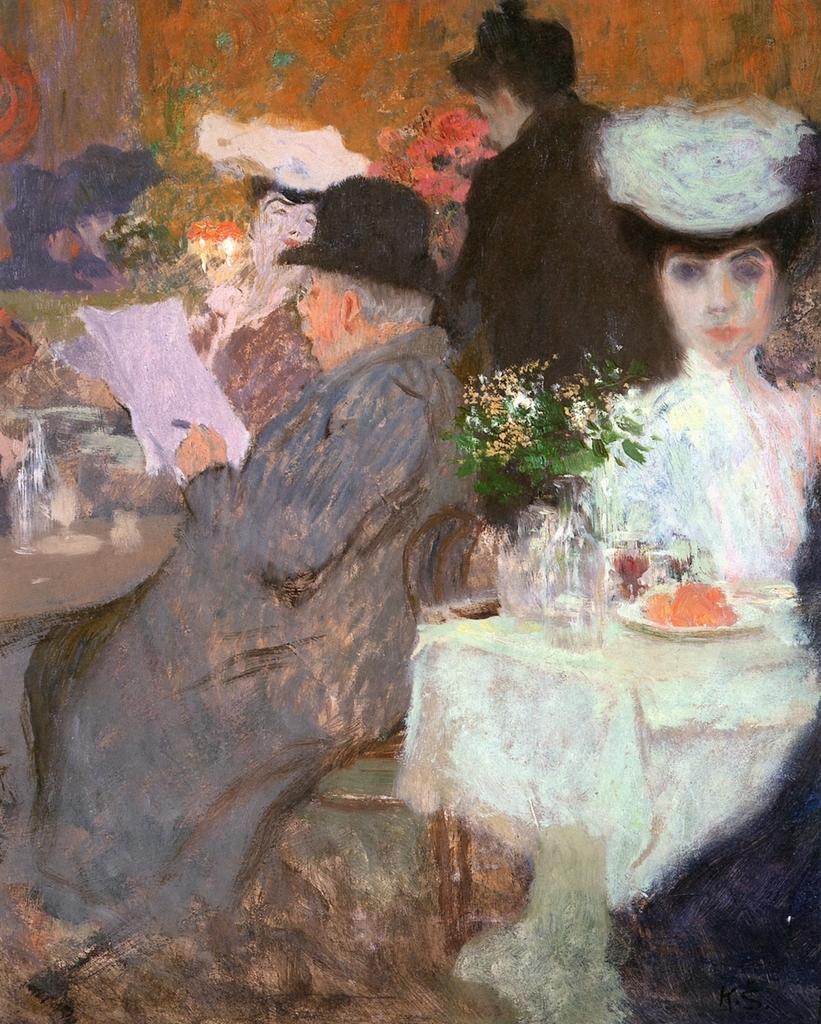How would you summarize this image in a sentence or two? This is a painting. There is a man sitting and holding the paper and there are two people sitting and there is a person standing. There are glasses, plates and objects on the tables and there is food on the plate. 